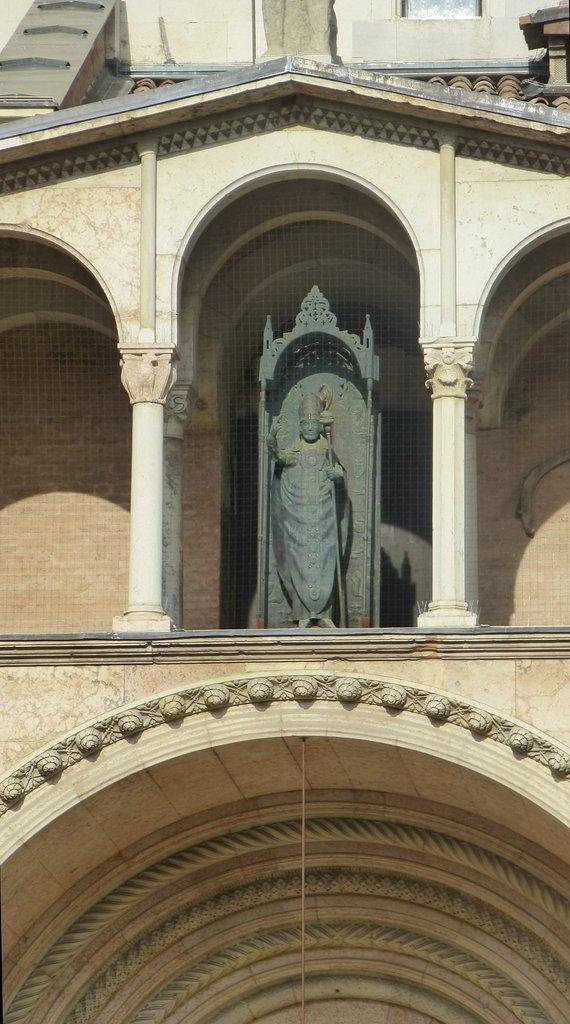What is the main subject in the image? There is a statue in the image. Can you describe the statue's surroundings? There is a wall in the background of the image. How much profit did the snake make in the image? There are no snakes or references to profit in the image. 